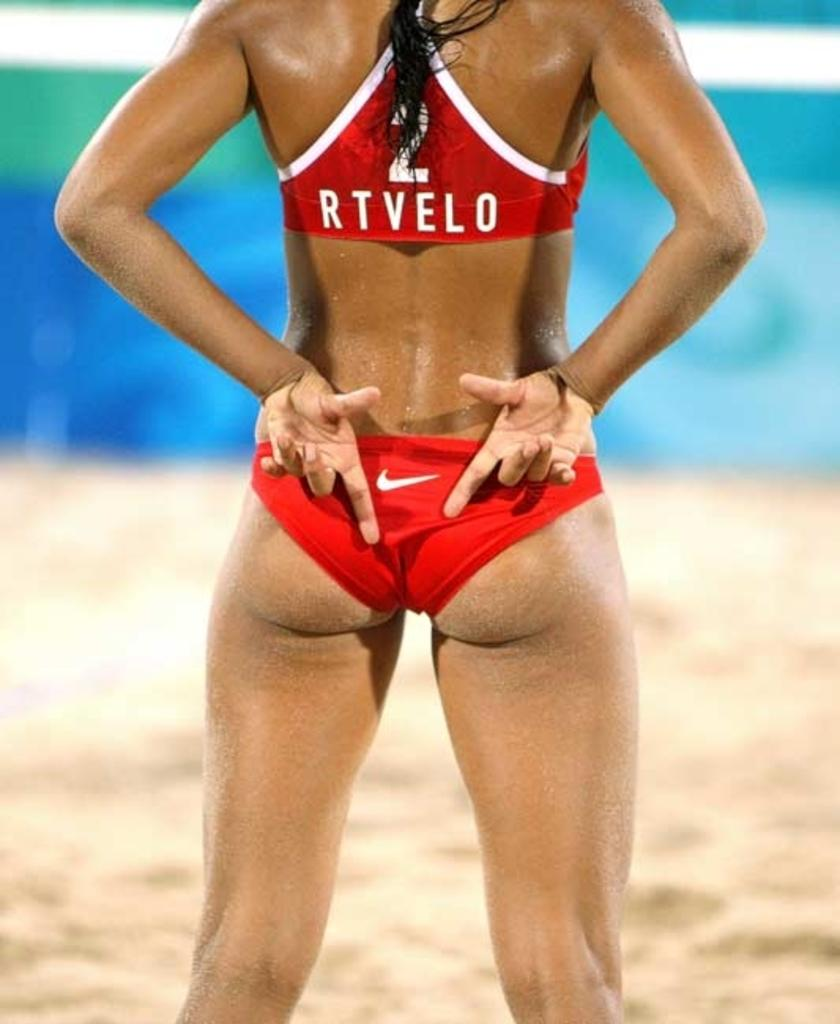<image>
Relay a brief, clear account of the picture shown. The back of a woman's athletic top says, "RTVELO." 